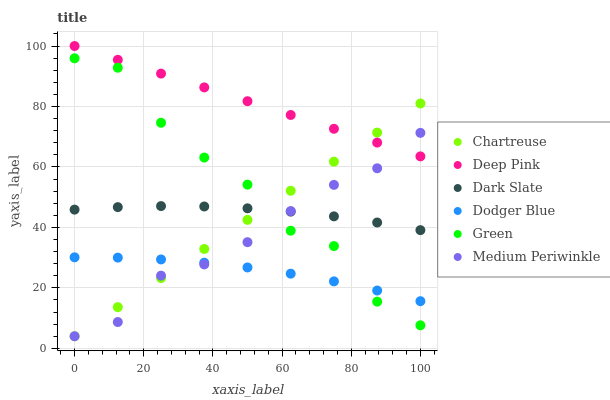Does Dodger Blue have the minimum area under the curve?
Answer yes or no. Yes. Does Deep Pink have the maximum area under the curve?
Answer yes or no. Yes. Does Medium Periwinkle have the minimum area under the curve?
Answer yes or no. No. Does Medium Periwinkle have the maximum area under the curve?
Answer yes or no. No. Is Chartreuse the smoothest?
Answer yes or no. Yes. Is Green the roughest?
Answer yes or no. Yes. Is Medium Periwinkle the smoothest?
Answer yes or no. No. Is Medium Periwinkle the roughest?
Answer yes or no. No. Does Medium Periwinkle have the lowest value?
Answer yes or no. Yes. Does Dark Slate have the lowest value?
Answer yes or no. No. Does Deep Pink have the highest value?
Answer yes or no. Yes. Does Medium Periwinkle have the highest value?
Answer yes or no. No. Is Dark Slate less than Deep Pink?
Answer yes or no. Yes. Is Deep Pink greater than Dodger Blue?
Answer yes or no. Yes. Does Chartreuse intersect Deep Pink?
Answer yes or no. Yes. Is Chartreuse less than Deep Pink?
Answer yes or no. No. Is Chartreuse greater than Deep Pink?
Answer yes or no. No. Does Dark Slate intersect Deep Pink?
Answer yes or no. No. 